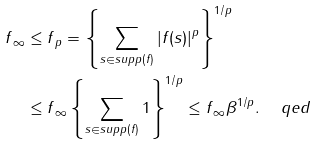Convert formula to latex. <formula><loc_0><loc_0><loc_500><loc_500>\| f \| _ { \infty } & \leq \| f \| _ { p } = \left \{ \sum _ { s \in s u p p ( f ) } | f ( s ) | ^ { p } \right \} ^ { 1 / p } \\ & \leq \| f \| _ { \infty } \left \{ \sum _ { s \in s u p p ( f ) } 1 \right \} ^ { 1 / p } \leq \| f \| _ { \infty } \beta ^ { 1 / p } . \quad \ q e d</formula> 